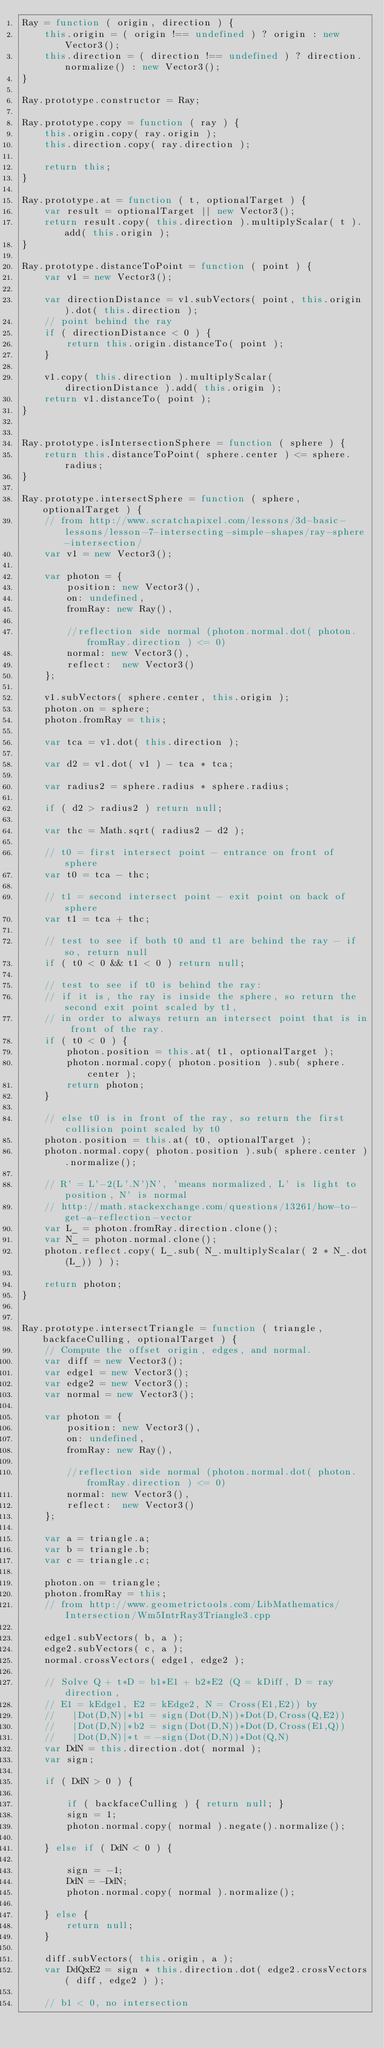<code> <loc_0><loc_0><loc_500><loc_500><_JavaScript_>Ray = function ( origin, direction ) {
    this.origin = ( origin !== undefined ) ? origin : new Vector3();
    this.direction = ( direction !== undefined ) ? direction.normalize() : new Vector3();
}

Ray.prototype.constructor = Ray;

Ray.prototype.copy = function ( ray ) {
    this.origin.copy( ray.origin );
    this.direction.copy( ray.direction );

    return this;
}

Ray.prototype.at = function ( t, optionalTarget ) {
    var result = optionalTarget || new Vector3();
    return result.copy( this.direction ).multiplyScalar( t ).add( this.origin );
}

Ray.prototype.distanceToPoint = function ( point ) {
    var v1 = new Vector3();

    var directionDistance = v1.subVectors( point, this.origin ).dot( this.direction );
    // point behind the ray
    if ( directionDistance < 0 ) {
        return this.origin.distanceTo( point );
    }

    v1.copy( this.direction ).multiplyScalar( directionDistance ).add( this.origin );
    return v1.distanceTo( point );
}


Ray.prototype.isIntersectionSphere = function ( sphere ) {
    return this.distanceToPoint( sphere.center ) <= sphere.radius;
}

Ray.prototype.intersectSphere = function ( sphere, optionalTarget ) {
    // from http://www.scratchapixel.com/lessons/3d-basic-lessons/lesson-7-intersecting-simple-shapes/ray-sphere-intersection/
    var v1 = new Vector3();

    var photon = {
        position: new Vector3(),
        on: undefined,
        fromRay: new Ray(),

        //reflection side normal (photon.normal.dot( photon.fromRay.direction ) <= 0)
        normal: new Vector3(),
        reflect:  new Vector3()
    };

    v1.subVectors( sphere.center, this.origin );
    photon.on = sphere;
    photon.fromRay = this;

    var tca = v1.dot( this.direction );

    var d2 = v1.dot( v1 ) - tca * tca;

    var radius2 = sphere.radius * sphere.radius;

    if ( d2 > radius2 ) return null;

    var thc = Math.sqrt( radius2 - d2 );

    // t0 = first intersect point - entrance on front of sphere
    var t0 = tca - thc;

    // t1 = second intersect point - exit point on back of sphere
    var t1 = tca + thc;

    // test to see if both t0 and t1 are behind the ray - if so, return null
    if ( t0 < 0 && t1 < 0 ) return null;

    // test to see if t0 is behind the ray:
    // if it is, the ray is inside the sphere, so return the second exit point scaled by t1,
    // in order to always return an intersect point that is in front of the ray.
    if ( t0 < 0 ) {
        photon.position = this.at( t1, optionalTarget );
        photon.normal.copy( photon.position ).sub( sphere.center );
        return photon;
    }

    // else t0 is in front of the ray, so return the first collision point scaled by t0
    photon.position = this.at( t0, optionalTarget );
    photon.normal.copy( photon.position ).sub( sphere.center ).normalize();

    // R' = L'-2(L'.N')N', 'means normalized, L' is light to position, N' is normal
    // http://math.stackexchange.com/questions/13261/how-to-get-a-reflection-vector
    var L_ = photon.fromRay.direction.clone();
    var N_ = photon.normal.clone();
    photon.reflect.copy( L_.sub( N_.multiplyScalar( 2 * N_.dot(L_)) ) );

    return photon;
}


Ray.prototype.intersectTriangle = function ( triangle, backfaceCulling, optionalTarget ) {
    // Compute the offset origin, edges, and normal.
    var diff = new Vector3();
    var edge1 = new Vector3();
    var edge2 = new Vector3();
    var normal = new Vector3();

    var photon = {
        position: new Vector3(),
        on: undefined,
        fromRay: new Ray(),

        //reflection side normal (photon.normal.dot( photon.fromRay.direction ) <= 0)
        normal: new Vector3(),
        reflect:  new Vector3()
    };

    var a = triangle.a;
    var b = triangle.b;
    var c = triangle.c;

    photon.on = triangle;
    photon.fromRay = this;
    // from http://www.geometrictools.com/LibMathematics/Intersection/Wm5IntrRay3Triangle3.cpp

    edge1.subVectors( b, a );
    edge2.subVectors( c, a );
    normal.crossVectors( edge1, edge2 );

    // Solve Q + t*D = b1*E1 + b2*E2 (Q = kDiff, D = ray direction,
    // E1 = kEdge1, E2 = kEdge2, N = Cross(E1,E2)) by
    //   |Dot(D,N)|*b1 = sign(Dot(D,N))*Dot(D,Cross(Q,E2))
    //   |Dot(D,N)|*b2 = sign(Dot(D,N))*Dot(D,Cross(E1,Q))
    //   |Dot(D,N)|*t = -sign(Dot(D,N))*Dot(Q,N)
    var DdN = this.direction.dot( normal );
    var sign;

    if ( DdN > 0 ) {

        if ( backfaceCulling ) { return null; }
        sign = 1;
        photon.normal.copy( normal ).negate().normalize();

    } else if ( DdN < 0 ) {

        sign = -1;
        DdN = -DdN;
        photon.normal.copy( normal ).normalize();

    } else {
        return null;
    }

    diff.subVectors( this.origin, a );
    var DdQxE2 = sign * this.direction.dot( edge2.crossVectors( diff, edge2 ) );

    // b1 < 0, no intersection</code> 